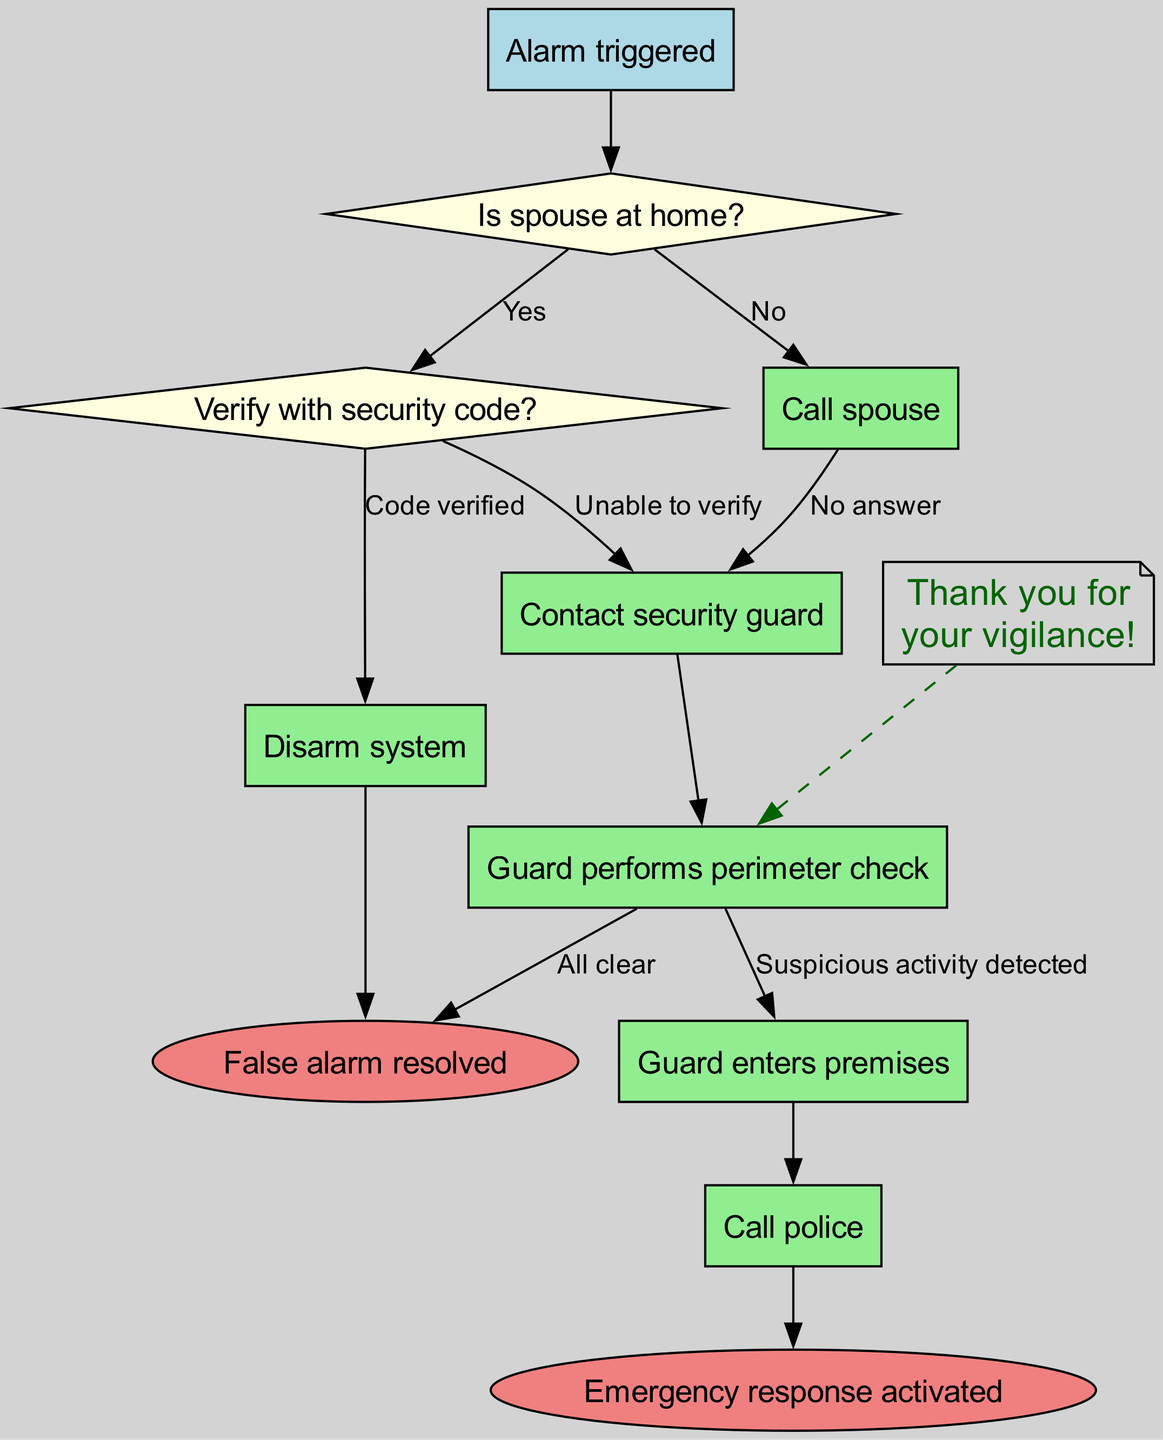What is the starting point of the diagram? The starting point, or the first node in the flow chart, is labeled "Alarm triggered." This is the initial action that sets off the entire emergency response procedure.
Answer: Alarm triggered How many decision nodes are in the diagram? There are two decision nodes in the diagram, which are "Is spouse at home?" and "Verify with security code?" These nodes represent points where a choice must be made.
Answer: 2 What happens if the spouse is at home? If the spouse is at home (indicated by the "Yes" edge from the decision node), the next action is to "Call spouse." Thus, the procedure continues from that action node.
Answer: Call spouse What action does the guard take after contacting security? After the guard is contacted, the next action taken is to perform a "Perimeter check." This step ensures that the area is secure before proceeding further.
Answer: Guard performs perimeter check What is the outcome if the system is disarmed? If the security system is disarmed (the action node "Disarm system"), the flow chart indicates that the outcome will be "False alarm resolved," which is one of the end nodes.
Answer: False alarm resolved What occurs after verifying the security code and it is correct? When the security code is verified correctly (labeled as "Code verified"), the next action in the flow is to "Disarm system." The procedure moves towards resolving the alarm situation.
Answer: Disarm system What is the final response if suspicious activity is detected? If suspicious activity is detected (leading from the action node), the final response is to "Call police." This denotes that immediate action is being taken in response to a possible threat.
Answer: Call police How does the gratitude note relate to the guard's actions? The gratitude note, saying "Thank you for your vigilance!", is linked to the action node "Guard performs perimeter check" through a dashed edge. This suggests an appreciation for the guard's attention during the security procedure.
Answer: Thank you for your vigilance! What is the purpose of the decision nodes in the flow? The decision nodes serve to guide the procedure based on specific circumstances, allowing for different pathways in the response based on the spouse's presence and the verification of the security code, thus tailoring the response.
Answer: Tailoring the response 